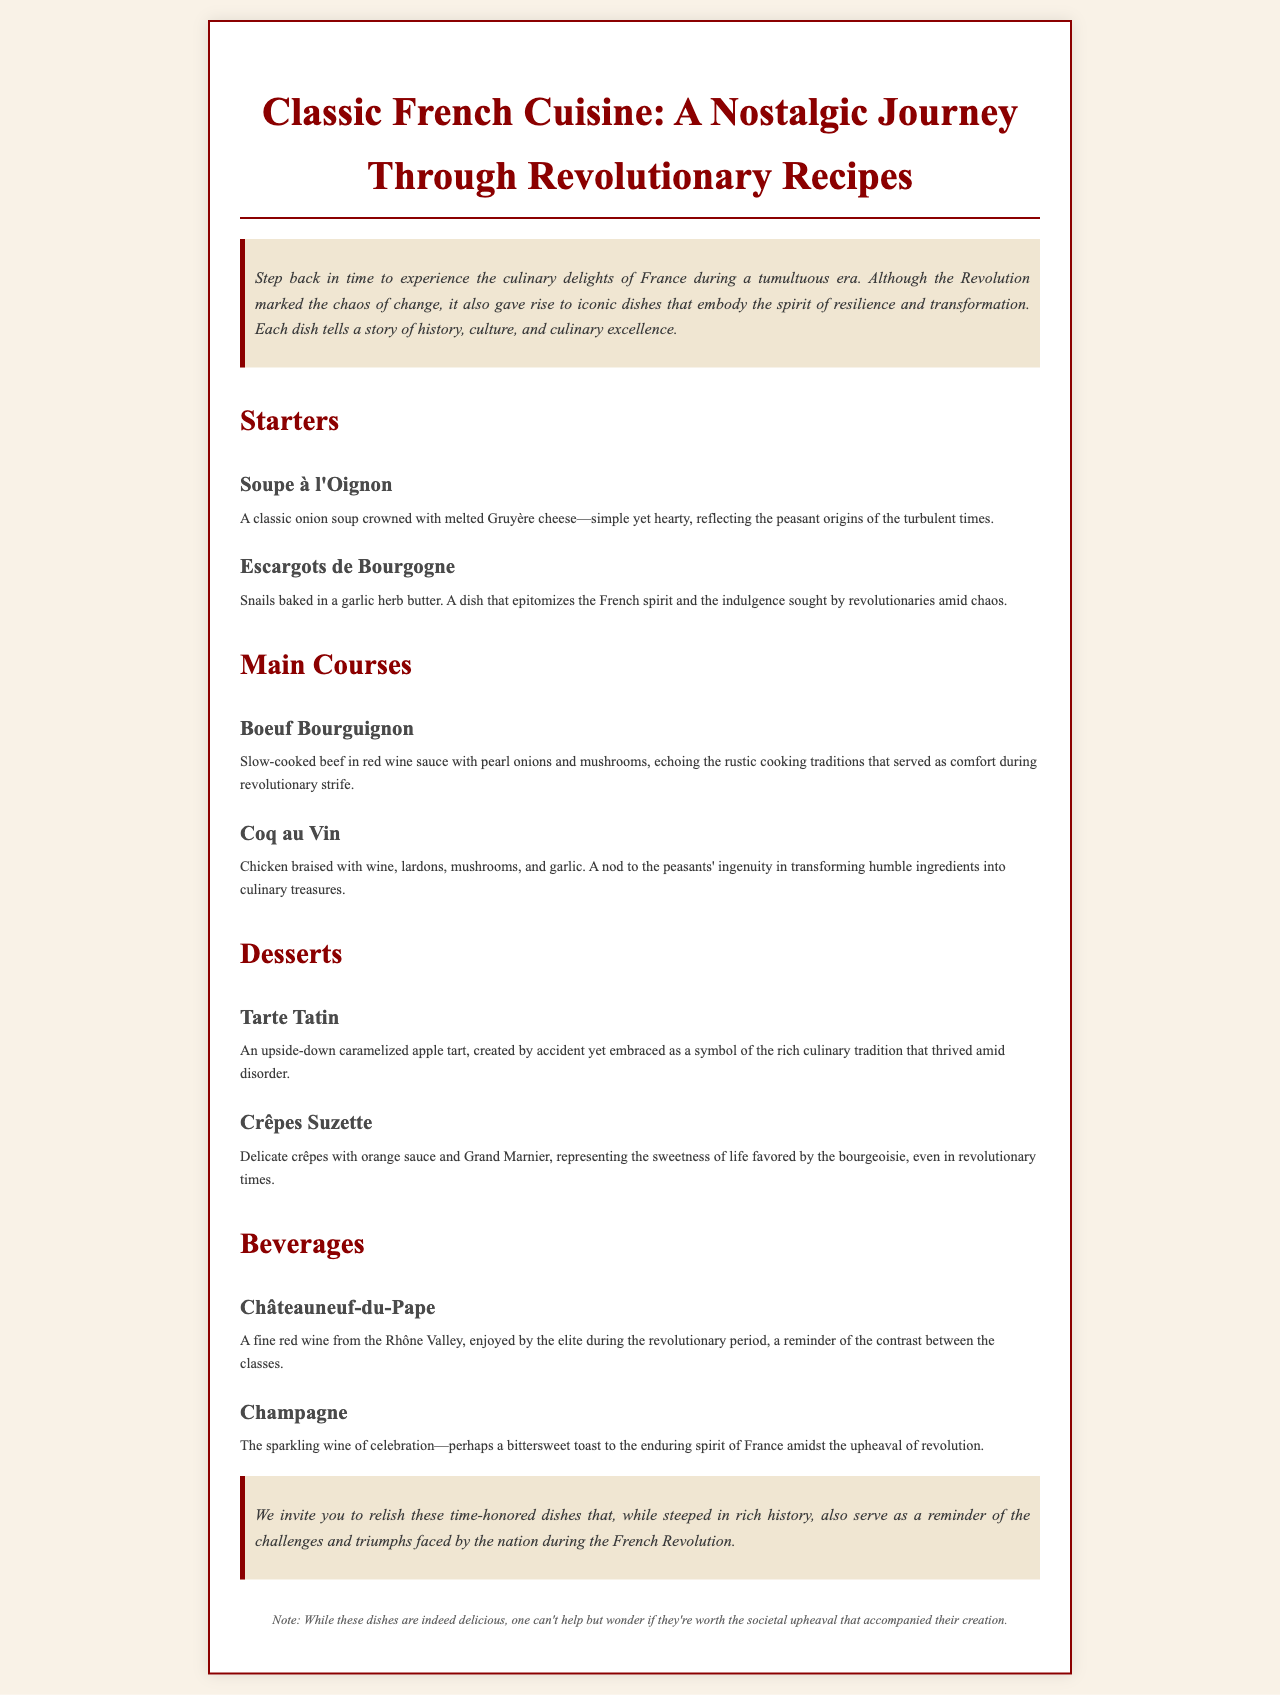What is the title of the menu? The title of the menu is stated clearly at the top of the document.
Answer: Classic French Cuisine: A Nostalgic Journey Through Revolutionary Recipes What are the two types of beverages listed? The document lists beverages under a specific section, which includes two categories.
Answer: Châteauneuf-du-Pape and Champagne How many main courses are featured? The document lists the main course dishes under a specific heading, allowing for a count.
Answer: 2 What is the first dessert mentioned? The first dessert is specified in the desserts section of the menu.
Answer: Tarte Tatin What does Soupe à l'Oignon reflect? The explanation of Soupe à l'Oignon provides insight into what it represents.
Answer: Peasant origins of the turbulent times What does the footnote suggest? The footnote at the end gives a critique or additional thought on the dishes.
Answer: Worth the societal upheaval? What is the style of the document? The document is formatted and styled in a specific manner suitable for a menu.
Answer: Restaurant menu What preparation method is mentioned for Coq au Vin? The description of Coq au Vin includes details about how it is prepared.
Answer: Braised with wine What story do these dishes tell? The introduction hints at the underlying theme of the dishes in the menu.
Answer: History and culinary excellence 